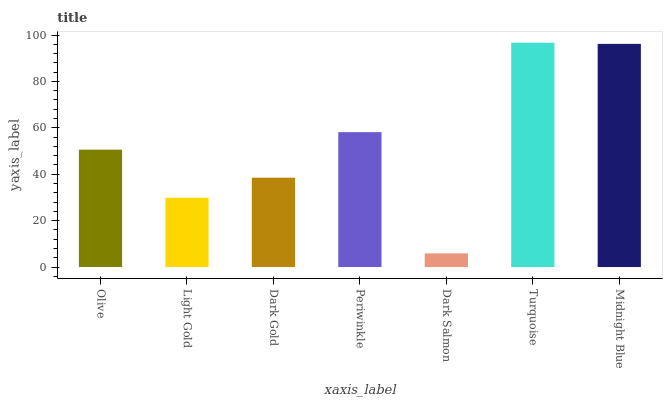Is Light Gold the minimum?
Answer yes or no. No. Is Light Gold the maximum?
Answer yes or no. No. Is Olive greater than Light Gold?
Answer yes or no. Yes. Is Light Gold less than Olive?
Answer yes or no. Yes. Is Light Gold greater than Olive?
Answer yes or no. No. Is Olive less than Light Gold?
Answer yes or no. No. Is Olive the high median?
Answer yes or no. Yes. Is Olive the low median?
Answer yes or no. Yes. Is Midnight Blue the high median?
Answer yes or no. No. Is Dark Gold the low median?
Answer yes or no. No. 